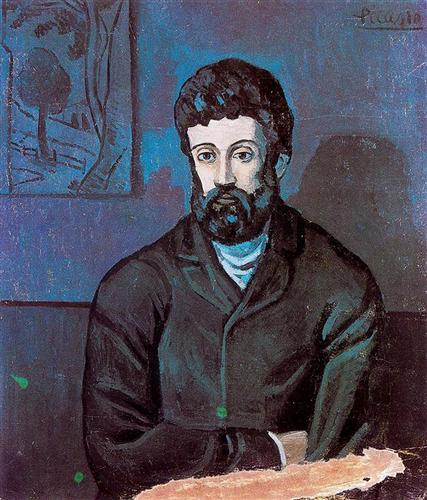What emotions do you think the man in the portrait is experiencing? The man in the portrait appears to be experiencing a sense of introspection and contemplation. His expression is somber, and the cool tones of blue and green that surround him contribute to a mood of quiet reflection. The depth in his eyes and the lines on his face suggest a person who is deep in thought, possibly grappling with complex emotions or memories. 